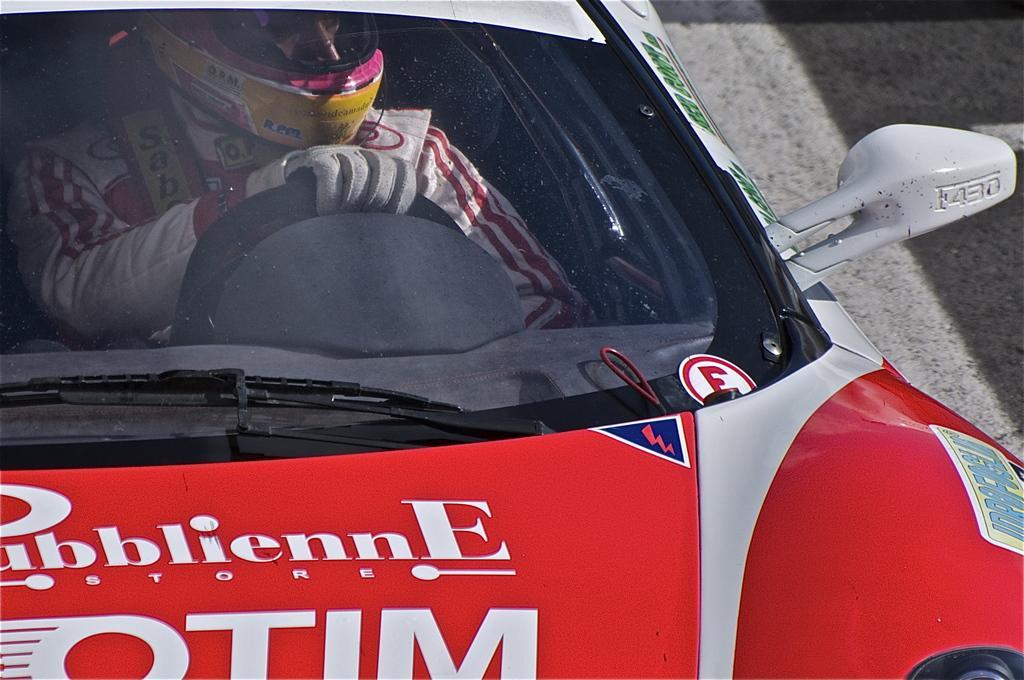How would you summarize this image in a sentence or two? In this picture we can see a person inside of a vehicle and this vehicle is on the ground. 